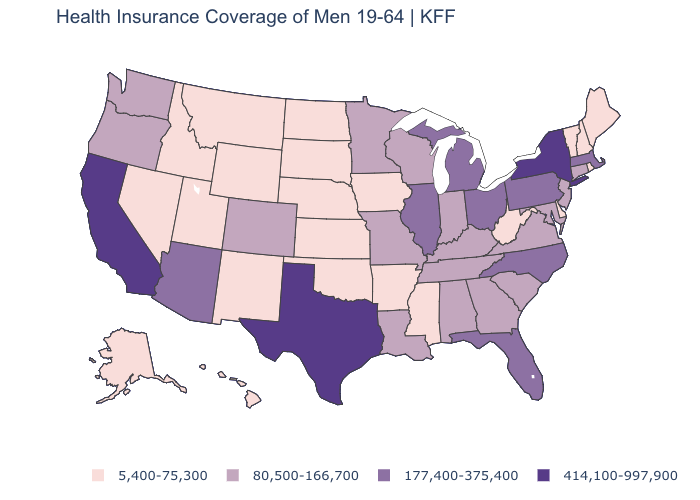Does Maine have the highest value in the USA?
Keep it brief. No. Does the map have missing data?
Keep it brief. No. Does New York have a higher value than South Carolina?
Write a very short answer. Yes. Among the states that border Ohio , which have the lowest value?
Answer briefly. West Virginia. Does the first symbol in the legend represent the smallest category?
Keep it brief. Yes. What is the lowest value in the Northeast?
Quick response, please. 5,400-75,300. Name the states that have a value in the range 5,400-75,300?
Be succinct. Alaska, Arkansas, Delaware, Hawaii, Idaho, Iowa, Kansas, Maine, Mississippi, Montana, Nebraska, Nevada, New Hampshire, New Mexico, North Dakota, Oklahoma, Rhode Island, South Dakota, Utah, Vermont, West Virginia, Wyoming. Does Missouri have the lowest value in the MidWest?
Keep it brief. No. Does the first symbol in the legend represent the smallest category?
Concise answer only. Yes. Among the states that border New York , which have the highest value?
Give a very brief answer. Massachusetts, Pennsylvania. What is the value of Ohio?
Concise answer only. 177,400-375,400. Name the states that have a value in the range 5,400-75,300?
Write a very short answer. Alaska, Arkansas, Delaware, Hawaii, Idaho, Iowa, Kansas, Maine, Mississippi, Montana, Nebraska, Nevada, New Hampshire, New Mexico, North Dakota, Oklahoma, Rhode Island, South Dakota, Utah, Vermont, West Virginia, Wyoming. Name the states that have a value in the range 414,100-997,900?
Give a very brief answer. California, New York, Texas. Name the states that have a value in the range 414,100-997,900?
Keep it brief. California, New York, Texas. 